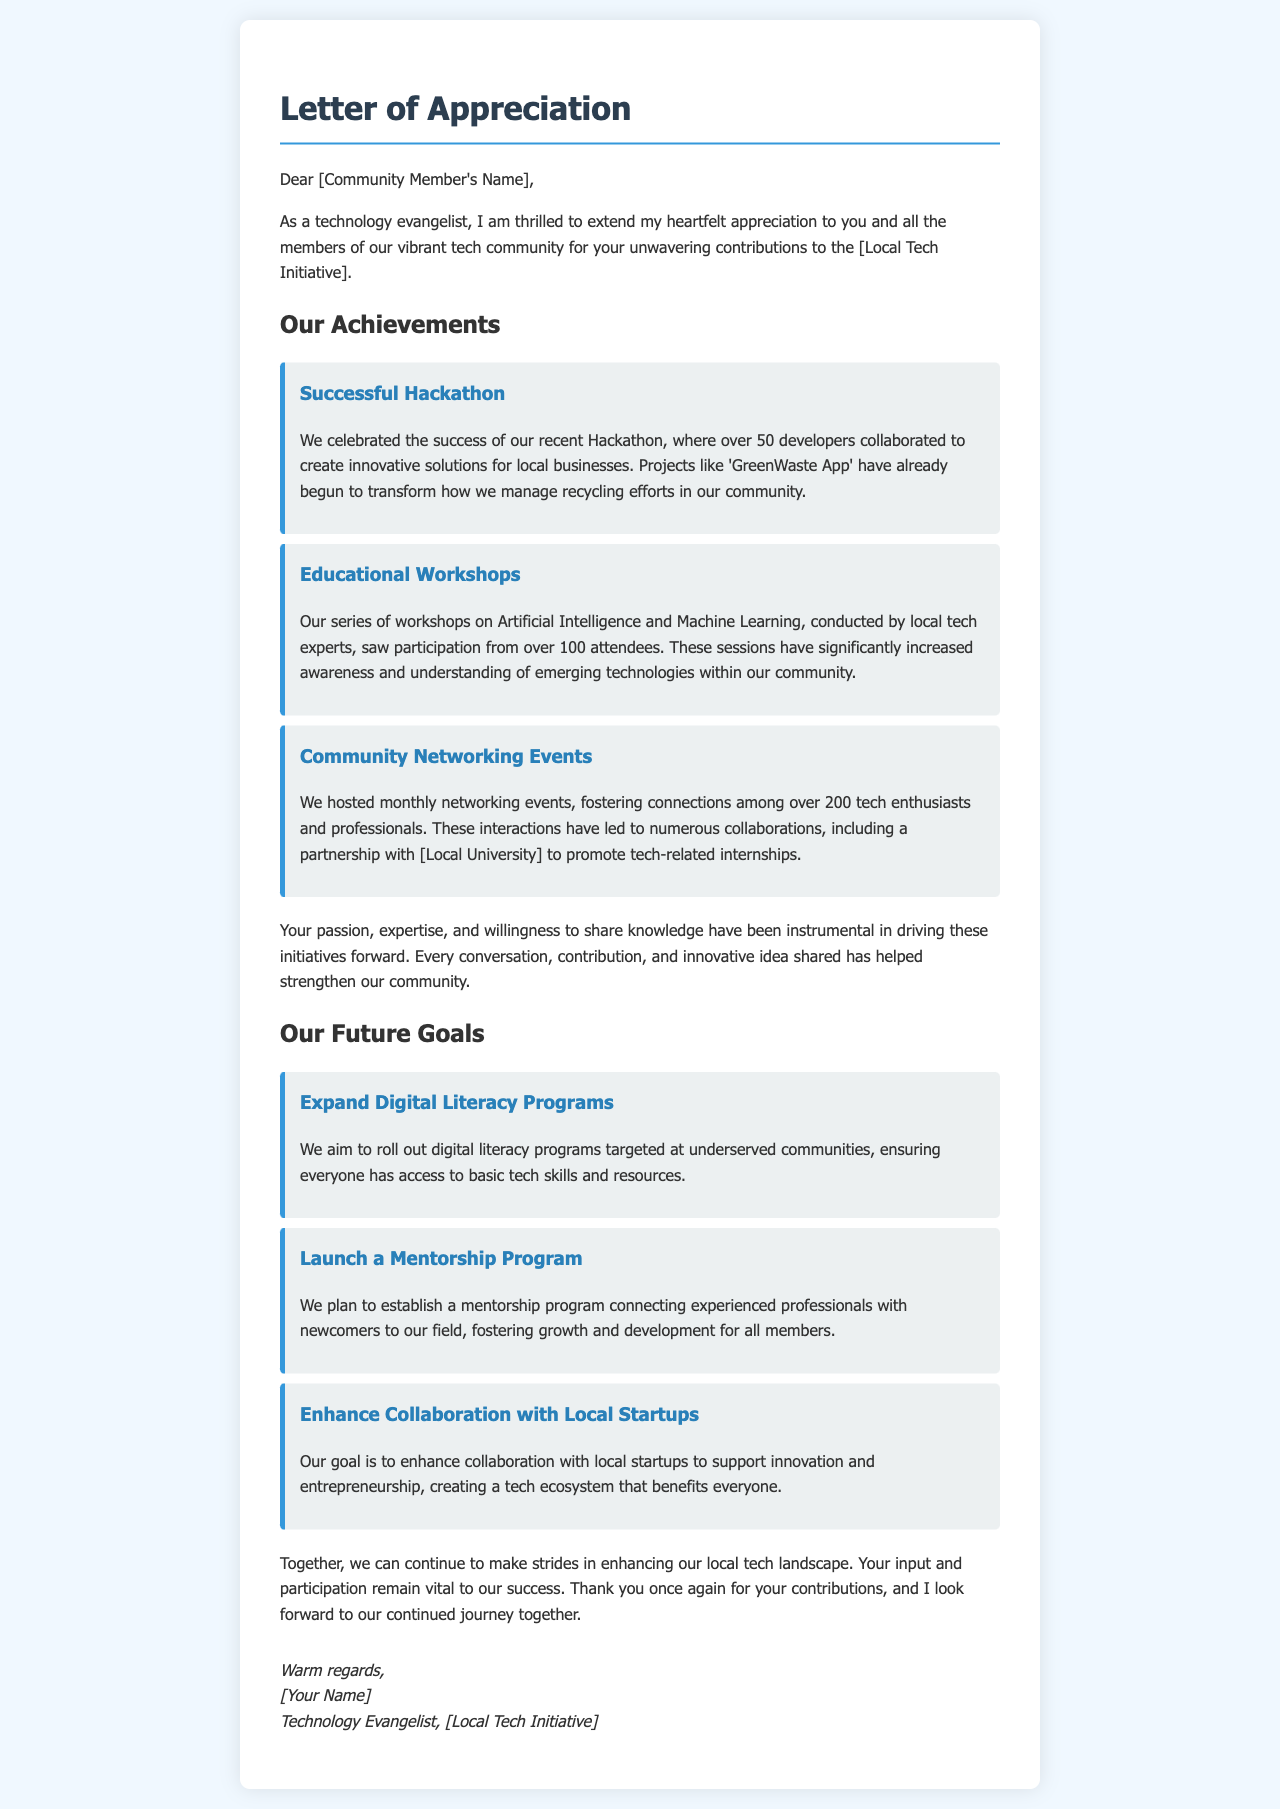What was the event that celebrated success with over 50 developers? The event mentioned is the Hackathon, where developers collaborated to create innovative solutions.
Answer: Hackathon How many attendees participated in the educational workshops? The document states that over 100 attendees participated in the workshops on Artificial Intelligence and Machine Learning.
Answer: 100 Which project is mentioned as transforming recycling efforts? The 'GreenWaste App' is highlighted as a project that has begun to improve recycling management.
Answer: GreenWaste App What is one of the future goals regarding underserved communities? The document outlines a goal to roll out digital literacy programs targeted at underserved communities.
Answer: Digital literacy programs What type of program is planned to connect experienced professionals with newcomers? A mentorship program is planned to facilitate connections and development for community members.
Answer: Mentorship program How many tech enthusiasts participated in monthly networking events? The document states that over 200 tech enthusiasts and professionals participated in the networking events.
Answer: 200 What is one way the local tech initiative plans to support innovation? The initiative aims to enhance collaboration with local startups to support innovation and entrepreneurship.
Answer: Enhance collaboration Who signed the letter? The letter is signed by the Technology Evangelist associated with the Local Tech Initiative.
Answer: [Your Name] What is crucial to the success of the local tech initiative? The document emphasizes that input and participation from community members are vital to the success.
Answer: Input and participation 